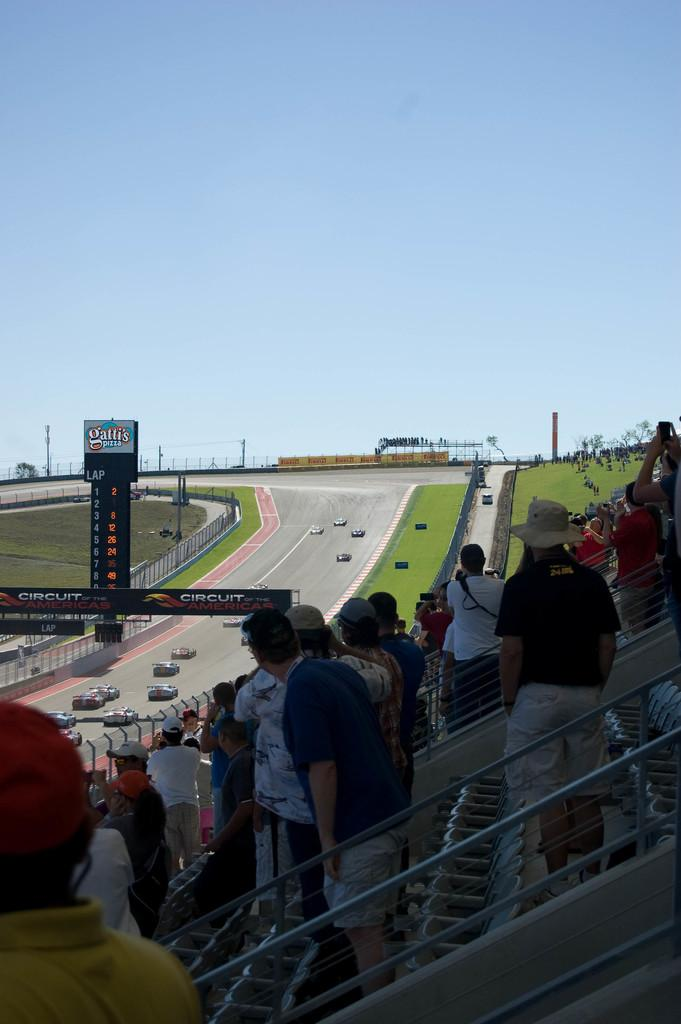How many people are visible at the bottom of the image? There are many people at the bottom of the image. What can be seen in the middle of the image? In the middle of the image, there are cars, posters, grass, a fence, trees, and the sky. What type of vegetation is present in the middle of the image? There are trees in the middle of the image. What is the purpose of the fence in the image? The purpose of the fence cannot be determined from the image alone. Can you see a squirrel climbing an icicle in the image? There is no squirrel or icicle present in the image. What is the purpose of the posters in the image? The purpose of the posters cannot be determined from the image alone. 